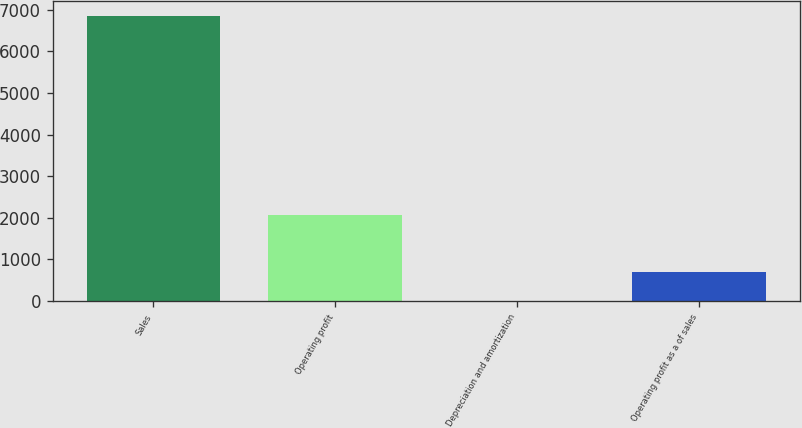<chart> <loc_0><loc_0><loc_500><loc_500><bar_chart><fcel>Sales<fcel>Operating profit<fcel>Depreciation and amortization<fcel>Operating profit as a of sales<nl><fcel>6856.4<fcel>2062.17<fcel>7.5<fcel>692.39<nl></chart> 